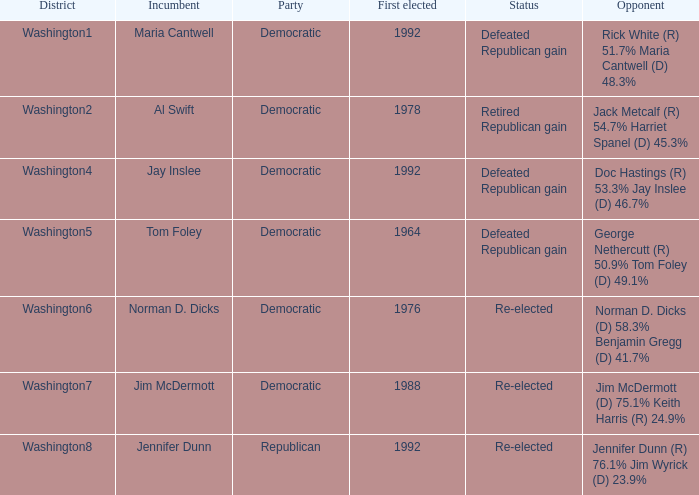What was the consequence of the election of doc hastings (r) 5 Defeated Republican gain. 